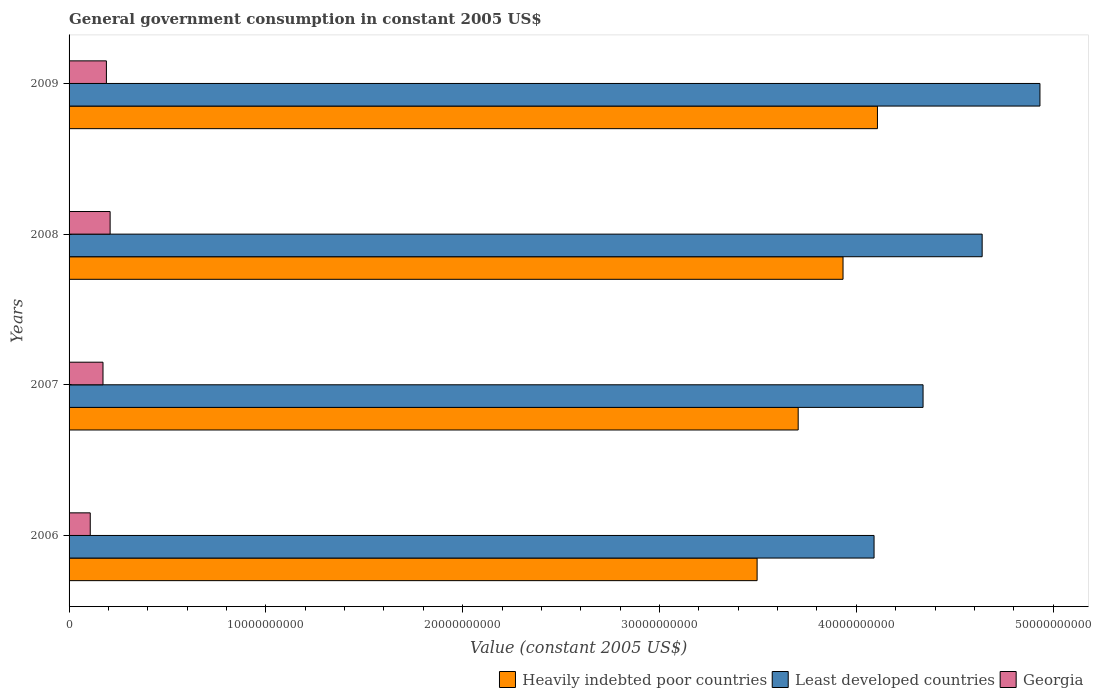How many different coloured bars are there?
Your answer should be compact. 3. How many groups of bars are there?
Keep it short and to the point. 4. How many bars are there on the 1st tick from the top?
Your answer should be very brief. 3. What is the government conusmption in Georgia in 2009?
Your answer should be compact. 1.90e+09. Across all years, what is the maximum government conusmption in Least developed countries?
Your answer should be very brief. 4.93e+1. Across all years, what is the minimum government conusmption in Least developed countries?
Offer a very short reply. 4.09e+1. In which year was the government conusmption in Least developed countries maximum?
Your response must be concise. 2009. In which year was the government conusmption in Least developed countries minimum?
Your answer should be compact. 2006. What is the total government conusmption in Least developed countries in the graph?
Your answer should be compact. 1.80e+11. What is the difference between the government conusmption in Georgia in 2007 and that in 2008?
Make the answer very short. -3.62e+08. What is the difference between the government conusmption in Heavily indebted poor countries in 2006 and the government conusmption in Least developed countries in 2008?
Ensure brevity in your answer.  -1.14e+1. What is the average government conusmption in Least developed countries per year?
Your response must be concise. 4.50e+1. In the year 2009, what is the difference between the government conusmption in Heavily indebted poor countries and government conusmption in Georgia?
Your response must be concise. 3.92e+1. What is the ratio of the government conusmption in Least developed countries in 2007 to that in 2008?
Offer a terse response. 0.94. Is the government conusmption in Georgia in 2006 less than that in 2009?
Make the answer very short. Yes. What is the difference between the highest and the second highest government conusmption in Least developed countries?
Offer a very short reply. 2.94e+09. What is the difference between the highest and the lowest government conusmption in Least developed countries?
Provide a short and direct response. 8.43e+09. What does the 1st bar from the top in 2009 represents?
Offer a terse response. Georgia. What does the 1st bar from the bottom in 2006 represents?
Offer a terse response. Heavily indebted poor countries. Is it the case that in every year, the sum of the government conusmption in Heavily indebted poor countries and government conusmption in Least developed countries is greater than the government conusmption in Georgia?
Provide a succinct answer. Yes. How many bars are there?
Offer a very short reply. 12. How many years are there in the graph?
Offer a terse response. 4. What is the difference between two consecutive major ticks on the X-axis?
Keep it short and to the point. 1.00e+1. Does the graph contain grids?
Provide a succinct answer. No. Where does the legend appear in the graph?
Keep it short and to the point. Bottom right. How are the legend labels stacked?
Keep it short and to the point. Horizontal. What is the title of the graph?
Ensure brevity in your answer.  General government consumption in constant 2005 US$. Does "Bahrain" appear as one of the legend labels in the graph?
Provide a short and direct response. No. What is the label or title of the X-axis?
Ensure brevity in your answer.  Value (constant 2005 US$). What is the Value (constant 2005 US$) of Heavily indebted poor countries in 2006?
Provide a succinct answer. 3.50e+1. What is the Value (constant 2005 US$) in Least developed countries in 2006?
Your response must be concise. 4.09e+1. What is the Value (constant 2005 US$) in Georgia in 2006?
Provide a short and direct response. 1.08e+09. What is the Value (constant 2005 US$) of Heavily indebted poor countries in 2007?
Your answer should be compact. 3.70e+1. What is the Value (constant 2005 US$) in Least developed countries in 2007?
Ensure brevity in your answer.  4.34e+1. What is the Value (constant 2005 US$) in Georgia in 2007?
Make the answer very short. 1.72e+09. What is the Value (constant 2005 US$) of Heavily indebted poor countries in 2008?
Your response must be concise. 3.93e+1. What is the Value (constant 2005 US$) of Least developed countries in 2008?
Give a very brief answer. 4.64e+1. What is the Value (constant 2005 US$) of Georgia in 2008?
Offer a very short reply. 2.09e+09. What is the Value (constant 2005 US$) in Heavily indebted poor countries in 2009?
Your response must be concise. 4.11e+1. What is the Value (constant 2005 US$) of Least developed countries in 2009?
Your answer should be compact. 4.93e+1. What is the Value (constant 2005 US$) in Georgia in 2009?
Ensure brevity in your answer.  1.90e+09. Across all years, what is the maximum Value (constant 2005 US$) of Heavily indebted poor countries?
Keep it short and to the point. 4.11e+1. Across all years, what is the maximum Value (constant 2005 US$) of Least developed countries?
Your answer should be very brief. 4.93e+1. Across all years, what is the maximum Value (constant 2005 US$) of Georgia?
Your answer should be very brief. 2.09e+09. Across all years, what is the minimum Value (constant 2005 US$) of Heavily indebted poor countries?
Offer a very short reply. 3.50e+1. Across all years, what is the minimum Value (constant 2005 US$) of Least developed countries?
Keep it short and to the point. 4.09e+1. Across all years, what is the minimum Value (constant 2005 US$) of Georgia?
Provide a short and direct response. 1.08e+09. What is the total Value (constant 2005 US$) of Heavily indebted poor countries in the graph?
Offer a terse response. 1.52e+11. What is the total Value (constant 2005 US$) of Least developed countries in the graph?
Your answer should be very brief. 1.80e+11. What is the total Value (constant 2005 US$) in Georgia in the graph?
Your response must be concise. 6.78e+09. What is the difference between the Value (constant 2005 US$) in Heavily indebted poor countries in 2006 and that in 2007?
Give a very brief answer. -2.09e+09. What is the difference between the Value (constant 2005 US$) in Least developed countries in 2006 and that in 2007?
Keep it short and to the point. -2.49e+09. What is the difference between the Value (constant 2005 US$) in Georgia in 2006 and that in 2007?
Provide a succinct answer. -6.48e+08. What is the difference between the Value (constant 2005 US$) in Heavily indebted poor countries in 2006 and that in 2008?
Your answer should be very brief. -4.37e+09. What is the difference between the Value (constant 2005 US$) of Least developed countries in 2006 and that in 2008?
Provide a short and direct response. -5.49e+09. What is the difference between the Value (constant 2005 US$) in Georgia in 2006 and that in 2008?
Your answer should be compact. -1.01e+09. What is the difference between the Value (constant 2005 US$) of Heavily indebted poor countries in 2006 and that in 2009?
Make the answer very short. -6.11e+09. What is the difference between the Value (constant 2005 US$) of Least developed countries in 2006 and that in 2009?
Give a very brief answer. -8.43e+09. What is the difference between the Value (constant 2005 US$) of Georgia in 2006 and that in 2009?
Offer a very short reply. -8.21e+08. What is the difference between the Value (constant 2005 US$) of Heavily indebted poor countries in 2007 and that in 2008?
Keep it short and to the point. -2.28e+09. What is the difference between the Value (constant 2005 US$) of Least developed countries in 2007 and that in 2008?
Give a very brief answer. -3.00e+09. What is the difference between the Value (constant 2005 US$) in Georgia in 2007 and that in 2008?
Your answer should be very brief. -3.62e+08. What is the difference between the Value (constant 2005 US$) in Heavily indebted poor countries in 2007 and that in 2009?
Provide a short and direct response. -4.03e+09. What is the difference between the Value (constant 2005 US$) of Least developed countries in 2007 and that in 2009?
Your answer should be very brief. -5.94e+09. What is the difference between the Value (constant 2005 US$) of Georgia in 2007 and that in 2009?
Your response must be concise. -1.74e+08. What is the difference between the Value (constant 2005 US$) of Heavily indebted poor countries in 2008 and that in 2009?
Ensure brevity in your answer.  -1.75e+09. What is the difference between the Value (constant 2005 US$) of Least developed countries in 2008 and that in 2009?
Your answer should be compact. -2.94e+09. What is the difference between the Value (constant 2005 US$) of Georgia in 2008 and that in 2009?
Provide a short and direct response. 1.89e+08. What is the difference between the Value (constant 2005 US$) in Heavily indebted poor countries in 2006 and the Value (constant 2005 US$) in Least developed countries in 2007?
Ensure brevity in your answer.  -8.43e+09. What is the difference between the Value (constant 2005 US$) of Heavily indebted poor countries in 2006 and the Value (constant 2005 US$) of Georgia in 2007?
Provide a short and direct response. 3.32e+1. What is the difference between the Value (constant 2005 US$) in Least developed countries in 2006 and the Value (constant 2005 US$) in Georgia in 2007?
Offer a terse response. 3.92e+1. What is the difference between the Value (constant 2005 US$) in Heavily indebted poor countries in 2006 and the Value (constant 2005 US$) in Least developed countries in 2008?
Offer a very short reply. -1.14e+1. What is the difference between the Value (constant 2005 US$) in Heavily indebted poor countries in 2006 and the Value (constant 2005 US$) in Georgia in 2008?
Give a very brief answer. 3.29e+1. What is the difference between the Value (constant 2005 US$) in Least developed countries in 2006 and the Value (constant 2005 US$) in Georgia in 2008?
Give a very brief answer. 3.88e+1. What is the difference between the Value (constant 2005 US$) in Heavily indebted poor countries in 2006 and the Value (constant 2005 US$) in Least developed countries in 2009?
Offer a very short reply. -1.44e+1. What is the difference between the Value (constant 2005 US$) of Heavily indebted poor countries in 2006 and the Value (constant 2005 US$) of Georgia in 2009?
Keep it short and to the point. 3.31e+1. What is the difference between the Value (constant 2005 US$) of Least developed countries in 2006 and the Value (constant 2005 US$) of Georgia in 2009?
Your answer should be very brief. 3.90e+1. What is the difference between the Value (constant 2005 US$) of Heavily indebted poor countries in 2007 and the Value (constant 2005 US$) of Least developed countries in 2008?
Your answer should be very brief. -9.35e+09. What is the difference between the Value (constant 2005 US$) in Heavily indebted poor countries in 2007 and the Value (constant 2005 US$) in Georgia in 2008?
Ensure brevity in your answer.  3.50e+1. What is the difference between the Value (constant 2005 US$) in Least developed countries in 2007 and the Value (constant 2005 US$) in Georgia in 2008?
Provide a succinct answer. 4.13e+1. What is the difference between the Value (constant 2005 US$) in Heavily indebted poor countries in 2007 and the Value (constant 2005 US$) in Least developed countries in 2009?
Your answer should be compact. -1.23e+1. What is the difference between the Value (constant 2005 US$) of Heavily indebted poor countries in 2007 and the Value (constant 2005 US$) of Georgia in 2009?
Give a very brief answer. 3.51e+1. What is the difference between the Value (constant 2005 US$) of Least developed countries in 2007 and the Value (constant 2005 US$) of Georgia in 2009?
Your answer should be compact. 4.15e+1. What is the difference between the Value (constant 2005 US$) in Heavily indebted poor countries in 2008 and the Value (constant 2005 US$) in Least developed countries in 2009?
Provide a succinct answer. -1.00e+1. What is the difference between the Value (constant 2005 US$) of Heavily indebted poor countries in 2008 and the Value (constant 2005 US$) of Georgia in 2009?
Offer a very short reply. 3.74e+1. What is the difference between the Value (constant 2005 US$) in Least developed countries in 2008 and the Value (constant 2005 US$) in Georgia in 2009?
Keep it short and to the point. 4.45e+1. What is the average Value (constant 2005 US$) of Heavily indebted poor countries per year?
Provide a succinct answer. 3.81e+1. What is the average Value (constant 2005 US$) of Least developed countries per year?
Make the answer very short. 4.50e+1. What is the average Value (constant 2005 US$) of Georgia per year?
Your response must be concise. 1.70e+09. In the year 2006, what is the difference between the Value (constant 2005 US$) in Heavily indebted poor countries and Value (constant 2005 US$) in Least developed countries?
Your answer should be compact. -5.94e+09. In the year 2006, what is the difference between the Value (constant 2005 US$) in Heavily indebted poor countries and Value (constant 2005 US$) in Georgia?
Ensure brevity in your answer.  3.39e+1. In the year 2006, what is the difference between the Value (constant 2005 US$) in Least developed countries and Value (constant 2005 US$) in Georgia?
Your response must be concise. 3.98e+1. In the year 2007, what is the difference between the Value (constant 2005 US$) of Heavily indebted poor countries and Value (constant 2005 US$) of Least developed countries?
Provide a short and direct response. -6.34e+09. In the year 2007, what is the difference between the Value (constant 2005 US$) of Heavily indebted poor countries and Value (constant 2005 US$) of Georgia?
Your answer should be compact. 3.53e+1. In the year 2007, what is the difference between the Value (constant 2005 US$) in Least developed countries and Value (constant 2005 US$) in Georgia?
Your response must be concise. 4.17e+1. In the year 2008, what is the difference between the Value (constant 2005 US$) in Heavily indebted poor countries and Value (constant 2005 US$) in Least developed countries?
Ensure brevity in your answer.  -7.07e+09. In the year 2008, what is the difference between the Value (constant 2005 US$) of Heavily indebted poor countries and Value (constant 2005 US$) of Georgia?
Offer a very short reply. 3.72e+1. In the year 2008, what is the difference between the Value (constant 2005 US$) of Least developed countries and Value (constant 2005 US$) of Georgia?
Your response must be concise. 4.43e+1. In the year 2009, what is the difference between the Value (constant 2005 US$) of Heavily indebted poor countries and Value (constant 2005 US$) of Least developed countries?
Offer a terse response. -8.26e+09. In the year 2009, what is the difference between the Value (constant 2005 US$) of Heavily indebted poor countries and Value (constant 2005 US$) of Georgia?
Provide a succinct answer. 3.92e+1. In the year 2009, what is the difference between the Value (constant 2005 US$) of Least developed countries and Value (constant 2005 US$) of Georgia?
Provide a succinct answer. 4.74e+1. What is the ratio of the Value (constant 2005 US$) of Heavily indebted poor countries in 2006 to that in 2007?
Your response must be concise. 0.94. What is the ratio of the Value (constant 2005 US$) of Least developed countries in 2006 to that in 2007?
Make the answer very short. 0.94. What is the ratio of the Value (constant 2005 US$) of Georgia in 2006 to that in 2007?
Provide a succinct answer. 0.62. What is the ratio of the Value (constant 2005 US$) in Heavily indebted poor countries in 2006 to that in 2008?
Provide a succinct answer. 0.89. What is the ratio of the Value (constant 2005 US$) of Least developed countries in 2006 to that in 2008?
Your answer should be very brief. 0.88. What is the ratio of the Value (constant 2005 US$) in Georgia in 2006 to that in 2008?
Your answer should be compact. 0.52. What is the ratio of the Value (constant 2005 US$) in Heavily indebted poor countries in 2006 to that in 2009?
Make the answer very short. 0.85. What is the ratio of the Value (constant 2005 US$) of Least developed countries in 2006 to that in 2009?
Offer a terse response. 0.83. What is the ratio of the Value (constant 2005 US$) in Georgia in 2006 to that in 2009?
Provide a succinct answer. 0.57. What is the ratio of the Value (constant 2005 US$) of Heavily indebted poor countries in 2007 to that in 2008?
Make the answer very short. 0.94. What is the ratio of the Value (constant 2005 US$) in Least developed countries in 2007 to that in 2008?
Your answer should be compact. 0.94. What is the ratio of the Value (constant 2005 US$) in Georgia in 2007 to that in 2008?
Your answer should be compact. 0.83. What is the ratio of the Value (constant 2005 US$) in Heavily indebted poor countries in 2007 to that in 2009?
Keep it short and to the point. 0.9. What is the ratio of the Value (constant 2005 US$) of Least developed countries in 2007 to that in 2009?
Your answer should be compact. 0.88. What is the ratio of the Value (constant 2005 US$) of Georgia in 2007 to that in 2009?
Your response must be concise. 0.91. What is the ratio of the Value (constant 2005 US$) of Heavily indebted poor countries in 2008 to that in 2009?
Ensure brevity in your answer.  0.96. What is the ratio of the Value (constant 2005 US$) in Least developed countries in 2008 to that in 2009?
Offer a very short reply. 0.94. What is the ratio of the Value (constant 2005 US$) in Georgia in 2008 to that in 2009?
Your answer should be very brief. 1.1. What is the difference between the highest and the second highest Value (constant 2005 US$) in Heavily indebted poor countries?
Offer a very short reply. 1.75e+09. What is the difference between the highest and the second highest Value (constant 2005 US$) of Least developed countries?
Offer a terse response. 2.94e+09. What is the difference between the highest and the second highest Value (constant 2005 US$) in Georgia?
Give a very brief answer. 1.89e+08. What is the difference between the highest and the lowest Value (constant 2005 US$) of Heavily indebted poor countries?
Provide a short and direct response. 6.11e+09. What is the difference between the highest and the lowest Value (constant 2005 US$) of Least developed countries?
Your answer should be very brief. 8.43e+09. What is the difference between the highest and the lowest Value (constant 2005 US$) of Georgia?
Your answer should be very brief. 1.01e+09. 